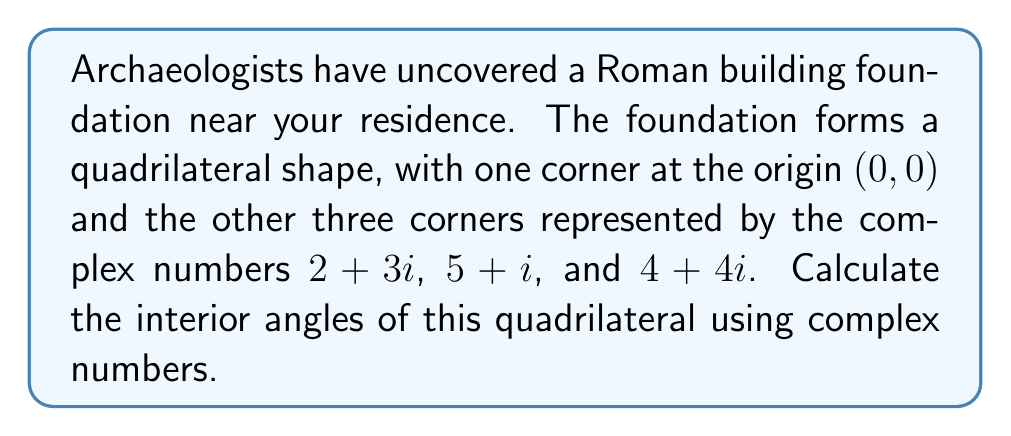Provide a solution to this math problem. Let's approach this step-by-step:

1) First, we need to calculate the vectors representing each side of the quadrilateral. We can do this by subtracting the complex numbers:

   $\vec{v_1} = (2+3i) - (0+0i) = 2+3i$
   $\vec{v_2} = (5+i) - (2+3i) = 3-2i$
   $\vec{v_3} = (4+4i) - (5+i) = -1+3i$
   $\vec{v_4} = (0+0i) - (4+4i) = -4-4i$

2) To find the angles, we'll use the formula for the angle between two complex numbers:

   $\theta = \arg(\frac{z_2}{z_1})$

   where $\arg(z)$ is the argument (angle) of the complex number $z$.

3) For the first angle (at the origin):
   $\theta_1 = \arg(\frac{-4-4i}{2+3i})$

4) For the second angle (at $2+3i$):
   $\theta_2 = \arg(\frac{3-2i}{-(-4-4i)}) = \arg(\frac{3-2i}{4+4i})$

5) For the third angle (at $5+i$):
   $\theta_3 = \arg(\frac{-1+3i}{-(3-2i)}) = \arg(\frac{-1+3i}{-3+2i})$

6) For the fourth angle (at $4+4i$):
   $\theta_4 = \arg(\frac{2+3i}{-(-1+3i)}) = \arg(\frac{2+3i}{1-3i})$

7) To calculate these arguments, we can use the arctangent function:

   $\arg(a+bi) = \arctan(\frac{b}{a})$ (adjusting for the correct quadrant)

8) Calculating each angle:

   $\theta_1 = \arctan(\frac{-14-6}{-2}) \approx 2.498$ radians or $143.1°$
   $\theta_2 = \arctan(\frac{20-6}{12+16}) \approx 0.588$ radians or $33.7°$
   $\theta_3 = \arctan(\frac{-7-3}{3+1}) \approx -1.909$ radians or $-109.4°$
   $\theta_4 = \arctan(\frac{11+3}{2-3}) \approx 2.965$ radians or $169.9°$

9) Note that $\theta_3$ is negative, so we add $2\pi$ to get the interior angle:
   $\theta_3 = -1.909 + 2\pi \approx 4.374$ radians or $250.6°$
Answer: $143.1°, 33.7°, 250.6°, 169.9°$ 